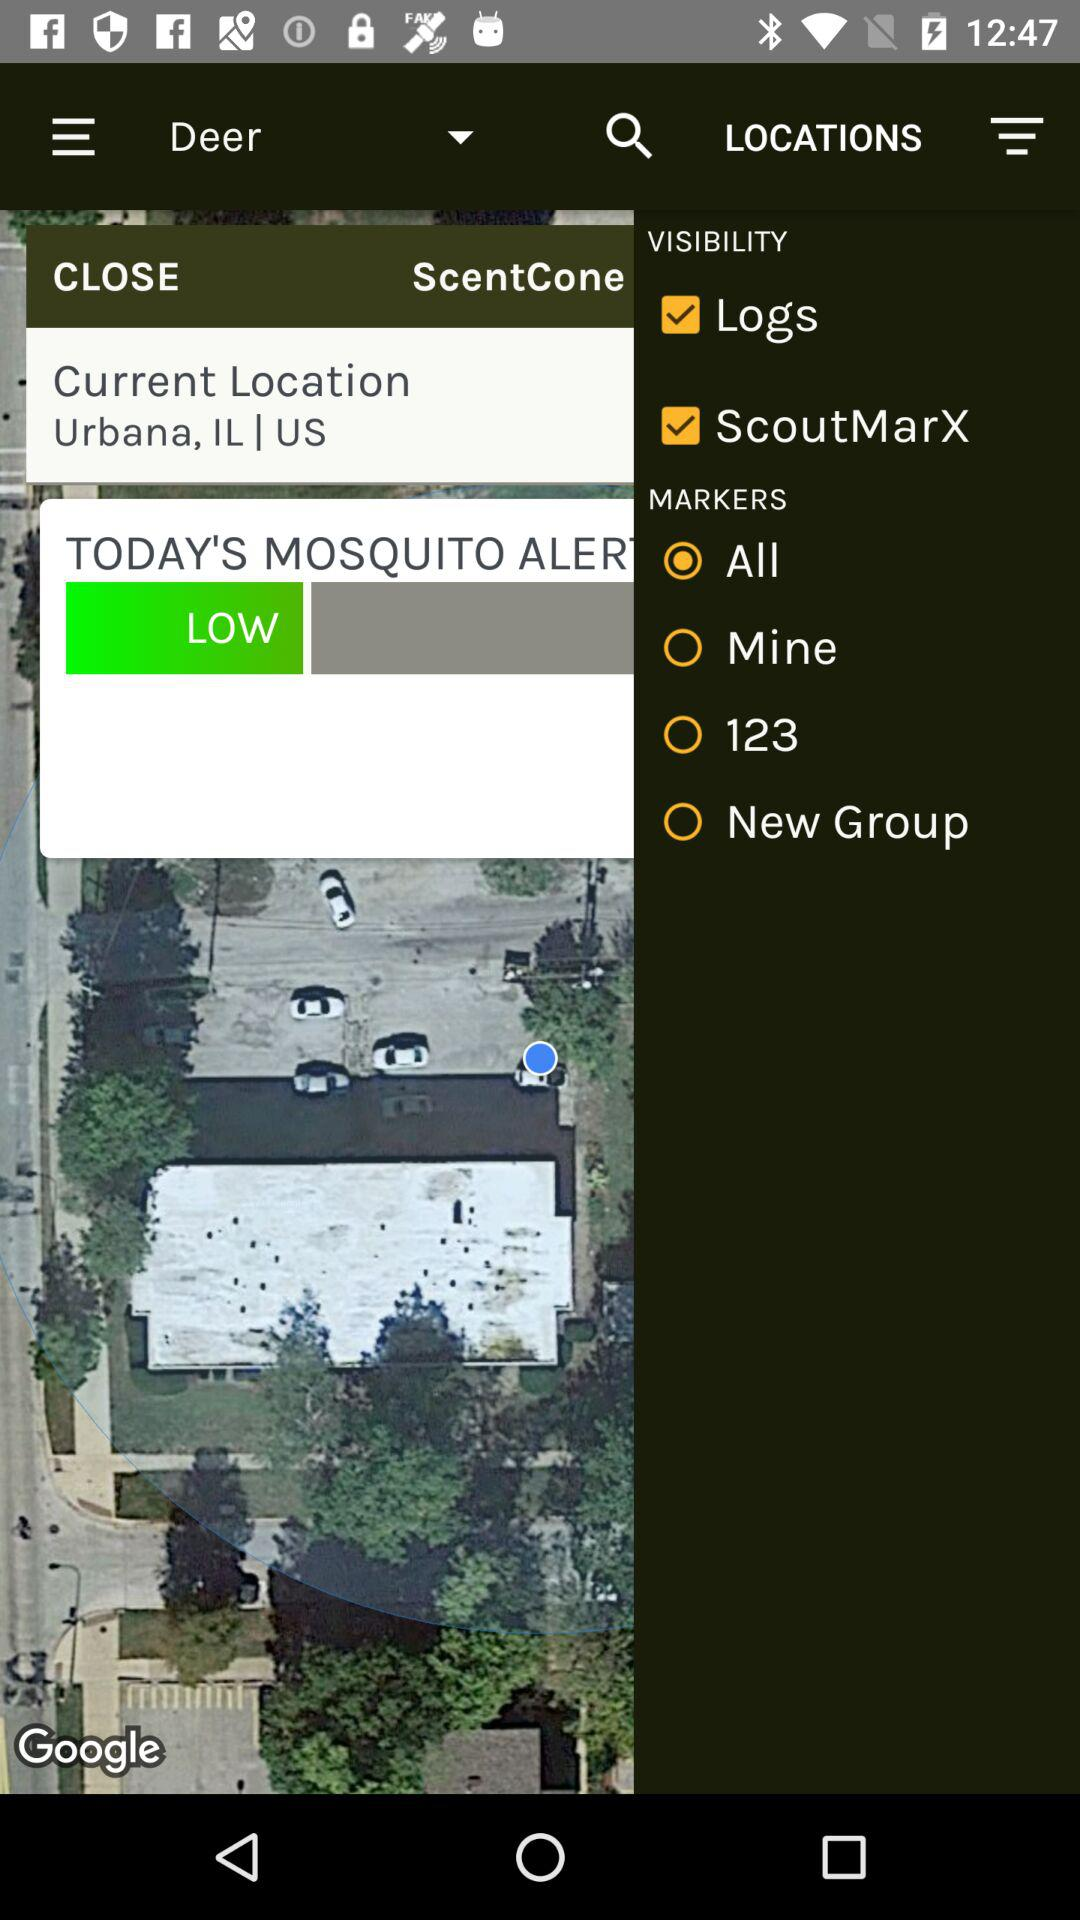Which "Markers" option is selected? The selected option is "All". 